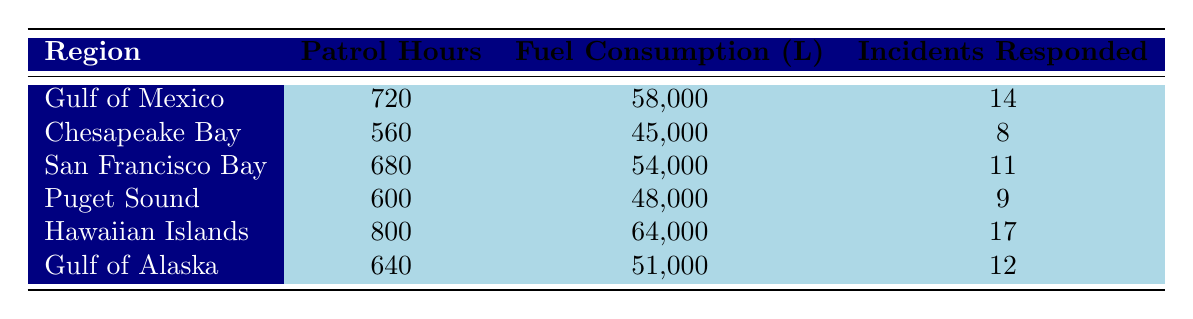What region has the highest number of patrol hours? The table lists patrol hours for each region. By comparing the values, the Hawaiian Islands have the highest patrol hours at 800.
Answer: Hawaiian Islands Which vessel responded to the most incidents? The table shows the incidents responded for each vessel. The USCGC Stone responded to 17 incidents, more than any other vessel.
Answer: USCGC Stone What is the total fuel consumption of all vessels in the Gulf of Mexico and Chesapeake Bay combined? The fuel consumption for the Gulf of Mexico is 58,000 liters and for Chesapeake Bay is 45,000 liters. Adding these gives 58,000 + 45,000 = 103,000 liters.
Answer: 103,000 liters Is it true that the USCGC Munro has more patrol hours than the USCGC Kimball? The table shows that USCGC Munro has 600 patrol hours and USCGC Kimball has 640 patrol hours. Therefore, the statement is false.
Answer: No What is the average number of incidents responded across all regions? The incidents responded total is 14 + 8 + 11 + 9 + 17 + 12 = 71. There are 6 regions; thus, the average is 71 / 6 ≈ 11.83.
Answer: 11.83 Which region has the lowest fuel consumption and what is that value? The fuel consumption values are compared, and Puget Sound has the lowest at 48,000 liters.
Answer: Puget Sound, 48,000 liters If we note the regions with more than 10 incidents responded, how many regions meet this criterion? The table lists regions with incidents responded: Gulf of Mexico (14), Hawaiian Islands (17), and Gulf of Alaska (12) totaling 3 regions over 10 incidents.
Answer: 3 regions What is the difference in patrol hours between the Gulf of Mexico and the San Francisco Bay? Gulf of Mexico has 720 patrol hours and San Francisco Bay has 680. The difference is 720 - 680 = 40 hours.
Answer: 40 hours Which vessel has the least fuel consumption, and what is the region it operates in? The table shows USCGC Munro with 48,000 liters of fuel consumption, operating in Puget Sound, making it the one with the least fuel consumption.
Answer: USCGC Munro, Puget Sound If USCGC Stratton and USCGC Kimball were deployed for an additional 100 patrol hours each, how many total patrol hours would they have? USCGC Stratton currently has 680 hours, and Kimball has 640. Adding the extra hours gives Stratton 780 and Kimball 740. The total is 780 + 740 = 1,520 patrol hours.
Answer: 1,520 patrol hours 